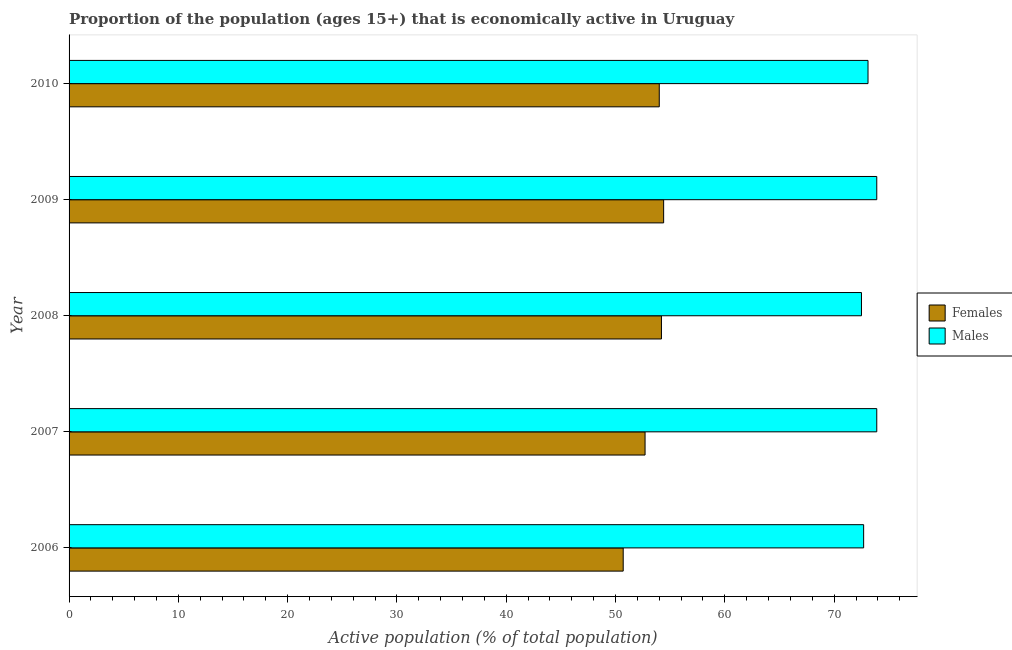Are the number of bars per tick equal to the number of legend labels?
Make the answer very short. Yes. How many bars are there on the 3rd tick from the top?
Your response must be concise. 2. What is the label of the 3rd group of bars from the top?
Your answer should be compact. 2008. What is the percentage of economically active male population in 2008?
Your answer should be compact. 72.5. Across all years, what is the maximum percentage of economically active male population?
Provide a succinct answer. 73.9. Across all years, what is the minimum percentage of economically active male population?
Ensure brevity in your answer.  72.5. What is the total percentage of economically active female population in the graph?
Provide a short and direct response. 266. What is the difference between the percentage of economically active female population in 2009 and the percentage of economically active male population in 2008?
Ensure brevity in your answer.  -18.1. What is the average percentage of economically active female population per year?
Make the answer very short. 53.2. In how many years, is the percentage of economically active female population greater than 48 %?
Offer a terse response. 5. What is the ratio of the percentage of economically active male population in 2008 to that in 2010?
Ensure brevity in your answer.  0.99. Is the percentage of economically active male population in 2008 less than that in 2009?
Your response must be concise. Yes. Is the difference between the percentage of economically active female population in 2006 and 2010 greater than the difference between the percentage of economically active male population in 2006 and 2010?
Provide a short and direct response. No. What is the difference between the highest and the second highest percentage of economically active male population?
Offer a terse response. 0. In how many years, is the percentage of economically active male population greater than the average percentage of economically active male population taken over all years?
Provide a succinct answer. 2. What does the 2nd bar from the top in 2007 represents?
Your answer should be very brief. Females. What does the 2nd bar from the bottom in 2006 represents?
Provide a succinct answer. Males. How many bars are there?
Offer a terse response. 10. Are all the bars in the graph horizontal?
Offer a very short reply. Yes. How many years are there in the graph?
Your answer should be compact. 5. How many legend labels are there?
Your response must be concise. 2. How are the legend labels stacked?
Ensure brevity in your answer.  Vertical. What is the title of the graph?
Make the answer very short. Proportion of the population (ages 15+) that is economically active in Uruguay. Does "Savings" appear as one of the legend labels in the graph?
Your answer should be very brief. No. What is the label or title of the X-axis?
Make the answer very short. Active population (% of total population). What is the Active population (% of total population) of Females in 2006?
Offer a terse response. 50.7. What is the Active population (% of total population) of Males in 2006?
Provide a succinct answer. 72.7. What is the Active population (% of total population) in Females in 2007?
Your response must be concise. 52.7. What is the Active population (% of total population) in Males in 2007?
Provide a succinct answer. 73.9. What is the Active population (% of total population) of Females in 2008?
Provide a succinct answer. 54.2. What is the Active population (% of total population) in Males in 2008?
Your answer should be very brief. 72.5. What is the Active population (% of total population) in Females in 2009?
Offer a very short reply. 54.4. What is the Active population (% of total population) in Males in 2009?
Offer a terse response. 73.9. What is the Active population (% of total population) in Males in 2010?
Provide a succinct answer. 73.1. Across all years, what is the maximum Active population (% of total population) of Females?
Keep it short and to the point. 54.4. Across all years, what is the maximum Active population (% of total population) in Males?
Offer a very short reply. 73.9. Across all years, what is the minimum Active population (% of total population) of Females?
Your answer should be compact. 50.7. Across all years, what is the minimum Active population (% of total population) in Males?
Give a very brief answer. 72.5. What is the total Active population (% of total population) in Females in the graph?
Give a very brief answer. 266. What is the total Active population (% of total population) of Males in the graph?
Keep it short and to the point. 366.1. What is the difference between the Active population (% of total population) in Males in 2006 and that in 2007?
Offer a very short reply. -1.2. What is the difference between the Active population (% of total population) in Males in 2006 and that in 2009?
Your response must be concise. -1.2. What is the difference between the Active population (% of total population) in Males in 2006 and that in 2010?
Offer a terse response. -0.4. What is the difference between the Active population (% of total population) in Males in 2007 and that in 2008?
Offer a terse response. 1.4. What is the difference between the Active population (% of total population) in Males in 2007 and that in 2009?
Keep it short and to the point. 0. What is the difference between the Active population (% of total population) of Females in 2007 and that in 2010?
Your response must be concise. -1.3. What is the difference between the Active population (% of total population) in Males in 2008 and that in 2010?
Give a very brief answer. -0.6. What is the difference between the Active population (% of total population) of Males in 2009 and that in 2010?
Provide a succinct answer. 0.8. What is the difference between the Active population (% of total population) of Females in 2006 and the Active population (% of total population) of Males in 2007?
Make the answer very short. -23.2. What is the difference between the Active population (% of total population) of Females in 2006 and the Active population (% of total population) of Males in 2008?
Give a very brief answer. -21.8. What is the difference between the Active population (% of total population) in Females in 2006 and the Active population (% of total population) in Males in 2009?
Provide a short and direct response. -23.2. What is the difference between the Active population (% of total population) of Females in 2006 and the Active population (% of total population) of Males in 2010?
Offer a terse response. -22.4. What is the difference between the Active population (% of total population) in Females in 2007 and the Active population (% of total population) in Males in 2008?
Your answer should be very brief. -19.8. What is the difference between the Active population (% of total population) of Females in 2007 and the Active population (% of total population) of Males in 2009?
Your response must be concise. -21.2. What is the difference between the Active population (% of total population) in Females in 2007 and the Active population (% of total population) in Males in 2010?
Your answer should be compact. -20.4. What is the difference between the Active population (% of total population) of Females in 2008 and the Active population (% of total population) of Males in 2009?
Provide a short and direct response. -19.7. What is the difference between the Active population (% of total population) in Females in 2008 and the Active population (% of total population) in Males in 2010?
Ensure brevity in your answer.  -18.9. What is the difference between the Active population (% of total population) in Females in 2009 and the Active population (% of total population) in Males in 2010?
Offer a terse response. -18.7. What is the average Active population (% of total population) in Females per year?
Provide a short and direct response. 53.2. What is the average Active population (% of total population) of Males per year?
Your answer should be compact. 73.22. In the year 2007, what is the difference between the Active population (% of total population) of Females and Active population (% of total population) of Males?
Your response must be concise. -21.2. In the year 2008, what is the difference between the Active population (% of total population) in Females and Active population (% of total population) in Males?
Your answer should be compact. -18.3. In the year 2009, what is the difference between the Active population (% of total population) in Females and Active population (% of total population) in Males?
Offer a very short reply. -19.5. In the year 2010, what is the difference between the Active population (% of total population) in Females and Active population (% of total population) in Males?
Offer a very short reply. -19.1. What is the ratio of the Active population (% of total population) of Males in 2006 to that in 2007?
Provide a short and direct response. 0.98. What is the ratio of the Active population (% of total population) in Females in 2006 to that in 2008?
Offer a terse response. 0.94. What is the ratio of the Active population (% of total population) of Females in 2006 to that in 2009?
Give a very brief answer. 0.93. What is the ratio of the Active population (% of total population) in Males in 2006 to that in 2009?
Your response must be concise. 0.98. What is the ratio of the Active population (% of total population) of Females in 2006 to that in 2010?
Offer a terse response. 0.94. What is the ratio of the Active population (% of total population) in Females in 2007 to that in 2008?
Provide a short and direct response. 0.97. What is the ratio of the Active population (% of total population) in Males in 2007 to that in 2008?
Give a very brief answer. 1.02. What is the ratio of the Active population (% of total population) in Females in 2007 to that in 2009?
Provide a succinct answer. 0.97. What is the ratio of the Active population (% of total population) of Males in 2007 to that in 2009?
Provide a short and direct response. 1. What is the ratio of the Active population (% of total population) of Females in 2007 to that in 2010?
Your answer should be very brief. 0.98. What is the ratio of the Active population (% of total population) of Males in 2007 to that in 2010?
Give a very brief answer. 1.01. What is the ratio of the Active population (% of total population) of Males in 2008 to that in 2009?
Provide a short and direct response. 0.98. What is the ratio of the Active population (% of total population) in Females in 2008 to that in 2010?
Offer a terse response. 1. What is the ratio of the Active population (% of total population) in Males in 2008 to that in 2010?
Make the answer very short. 0.99. What is the ratio of the Active population (% of total population) in Females in 2009 to that in 2010?
Ensure brevity in your answer.  1.01. What is the ratio of the Active population (% of total population) of Males in 2009 to that in 2010?
Keep it short and to the point. 1.01. 